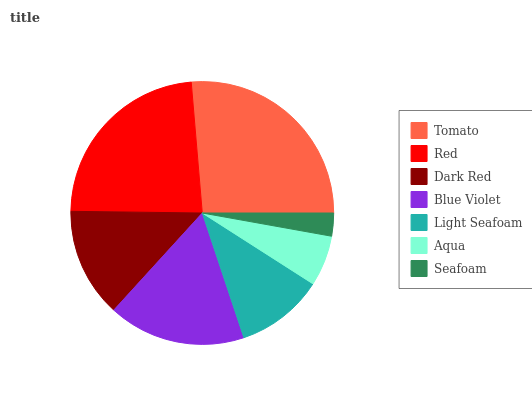Is Seafoam the minimum?
Answer yes or no. Yes. Is Tomato the maximum?
Answer yes or no. Yes. Is Red the minimum?
Answer yes or no. No. Is Red the maximum?
Answer yes or no. No. Is Tomato greater than Red?
Answer yes or no. Yes. Is Red less than Tomato?
Answer yes or no. Yes. Is Red greater than Tomato?
Answer yes or no. No. Is Tomato less than Red?
Answer yes or no. No. Is Dark Red the high median?
Answer yes or no. Yes. Is Dark Red the low median?
Answer yes or no. Yes. Is Red the high median?
Answer yes or no. No. Is Red the low median?
Answer yes or no. No. 